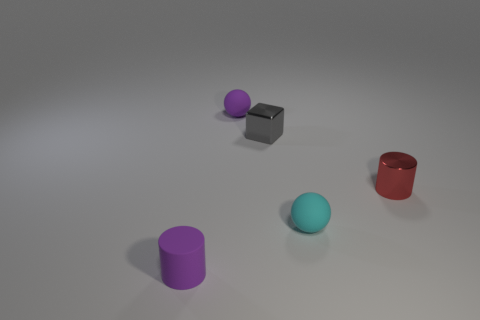Add 3 shiny blocks. How many objects exist? 8 Subtract all blocks. How many objects are left? 4 Add 4 tiny red metal objects. How many tiny red metal objects are left? 5 Add 5 tiny purple rubber cylinders. How many tiny purple rubber cylinders exist? 6 Subtract 0 blue cylinders. How many objects are left? 5 Subtract all large matte things. Subtract all tiny rubber objects. How many objects are left? 2 